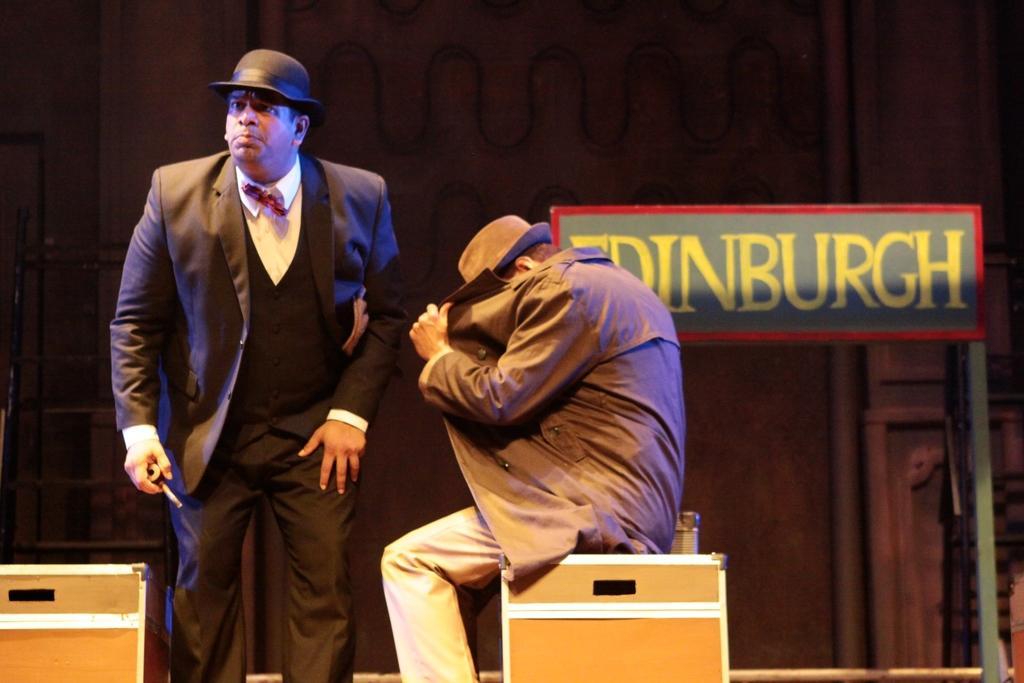Could you give a brief overview of what you see in this image? In this picture we can see a man in the black blazer is standing and the other man is sitting on a wooden box. Behind the people there is a board and a wall. 